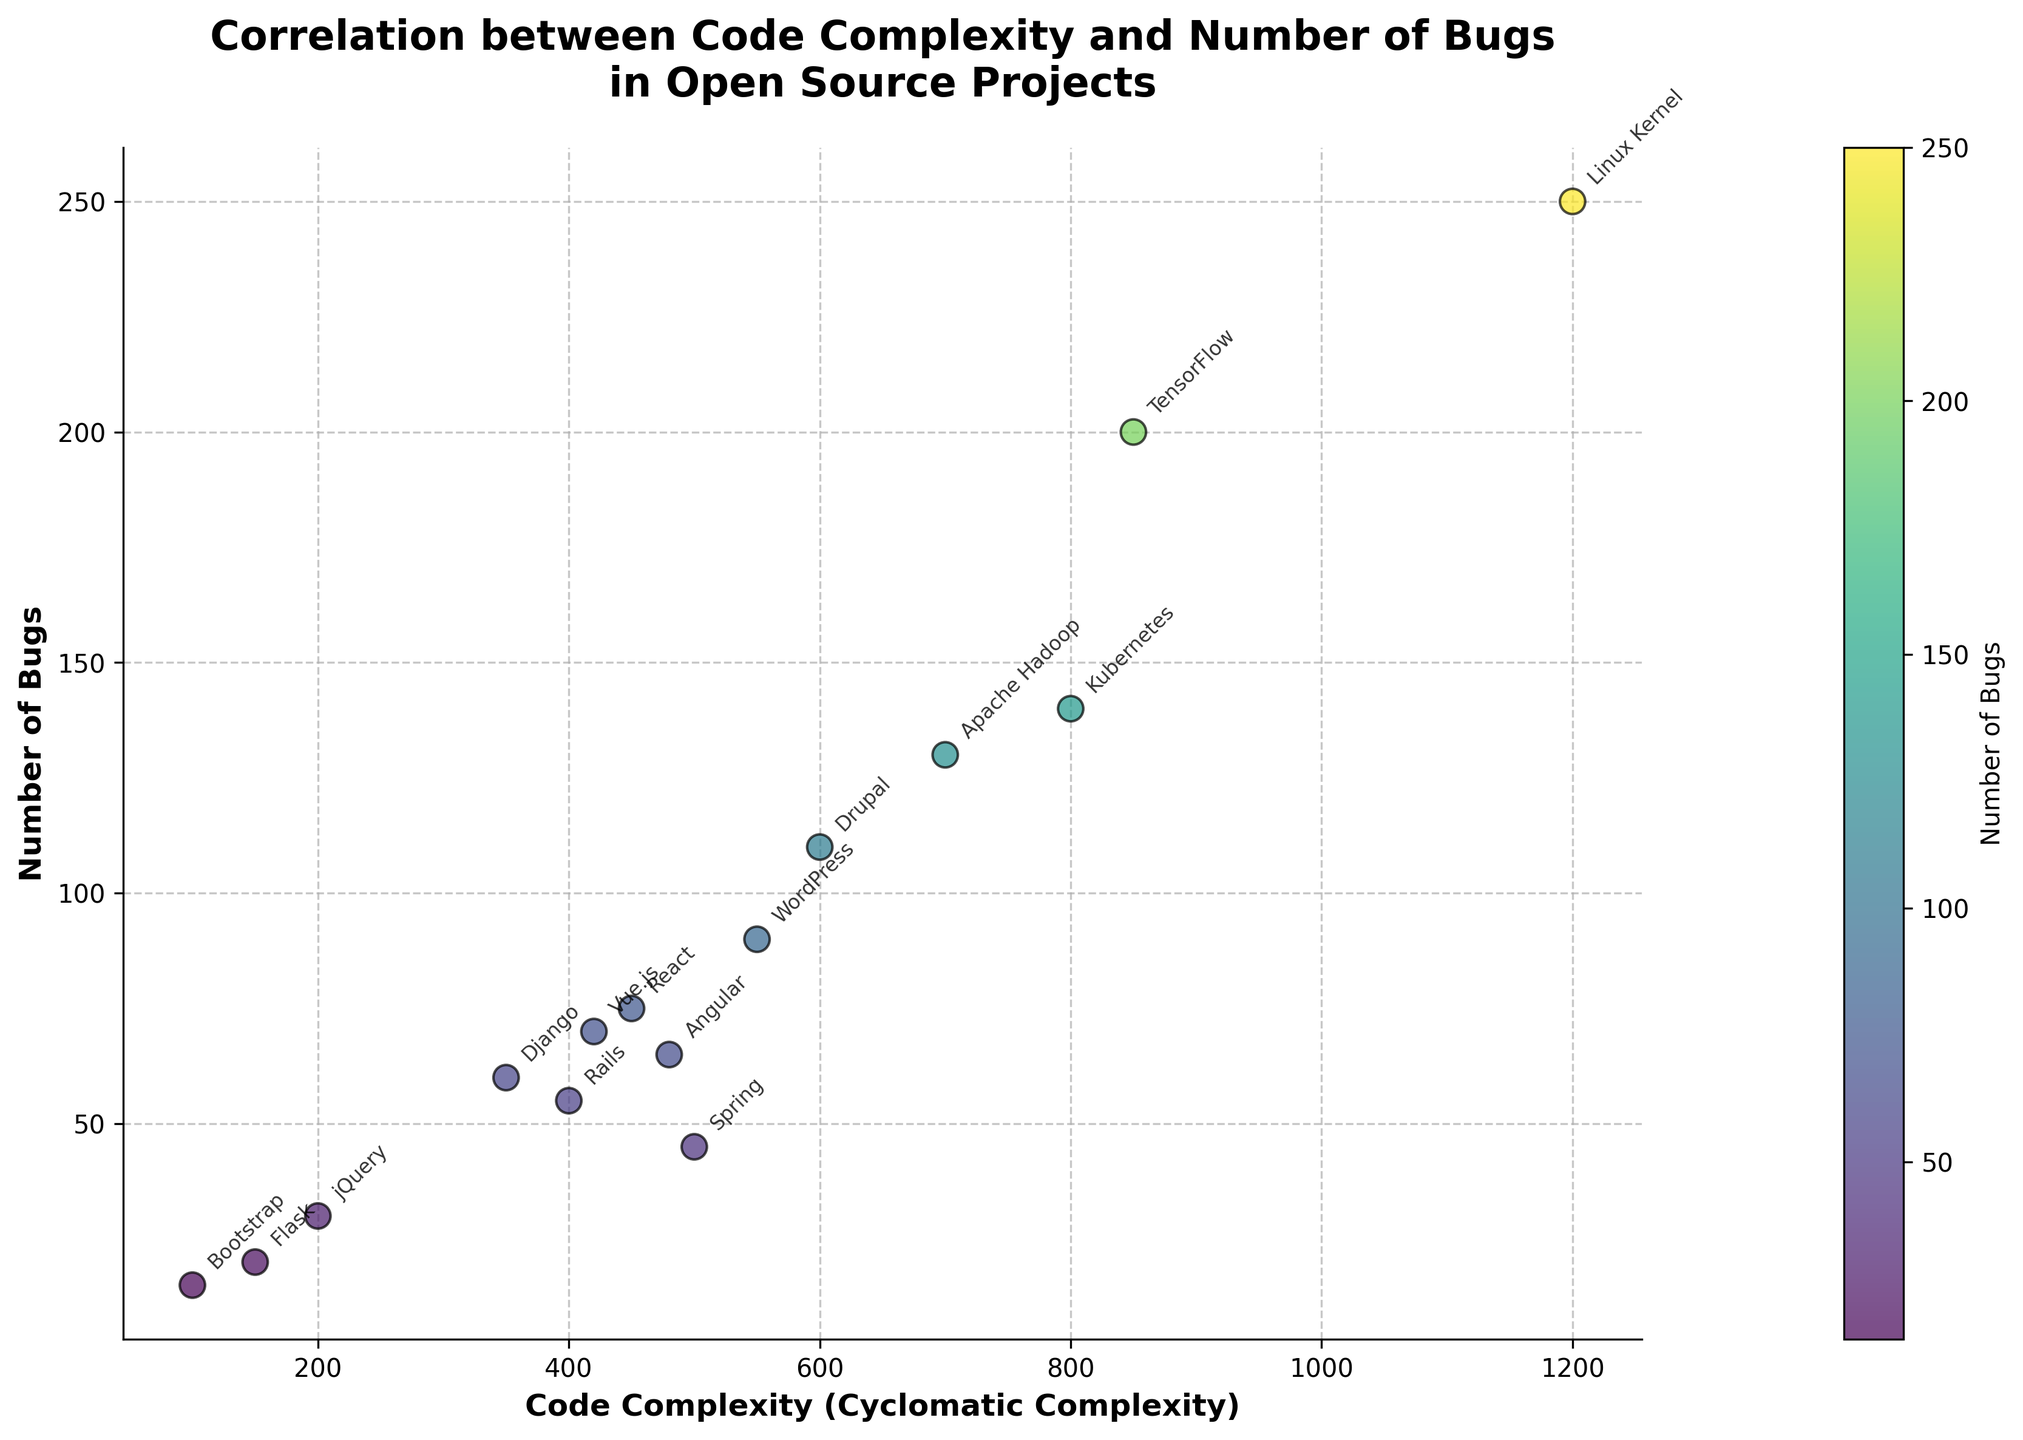What is the title of the figure? The title is usually displayed at the top of the figure. The title in this figure reads "Correlation between Code Complexity and Number of Bugs in Open Source Projects".
Answer: Correlation between Code Complexity and Number of Bugs in Open Source Projects What is the code complexity of the Linux Kernel project? The code complexity is shown on the x-axis, and the Linux Kernel data point is labeled on the figure. The corresponding x-value is 1200.
Answer: 1200 How many projects have a bug count above 100? By checking the y-axis which represents the Number of Bugs, identify the data points above 100. These projects are Drupal, Apache Hadoop, Kubernetes, and Linux Kernel (total of 4 projects).
Answer: 4 Which project has the lowest code complexity? Identify the data point with the smallest x-value. The lowest code complexity among the projects is Flask, with a complexity of 150.
Answer: Flask What is the average number of bugs for projects with code complexity below 500? Look at the data points with an x-value (code complexity) less than 500, then calculate the average y-value (number of bugs). The projects meeting this criterion are React (75), Vue.js (70), Django (60), Rails (55), Flask (20), Bootstrap (15), and jQuery (30). The total number of bugs is 325, and the number of projects is 7, so the average = 325/7.
Answer: 46.4 Which project has the highest number of bugs given a complexity below 600? Identify data points with x-values (code complexity) below 600 and find the one with the highest y-value. Drupal has the highest number of bugs with 110 for complexity below 600.
Answer: Drupal Is there a visible trend between code complexity and number of bugs? Based on the scatter plot, observe whether the number of bugs tends to increase with increasing code complexity. There appears to be a general upward trend when comparing corresponding values on the x and y axes.
Answer: Yes Compare the number of bugs in TensorFlow and Apache Hadoop. Which is higher? Locate both data points on the plot. TensorFlow has 200 bugs, and Apache Hadoop has 130 bugs. TensorFlow has a higher number of bugs than Apache Hadoop.
Answer: TensorFlow What does the color intensity of the points represent in the scatter plot? The color intensity, shown by the color bar next to the plot, represents the number of bugs. Darker colors indicate a higher number of bugs.
Answer: Number of Bugs 